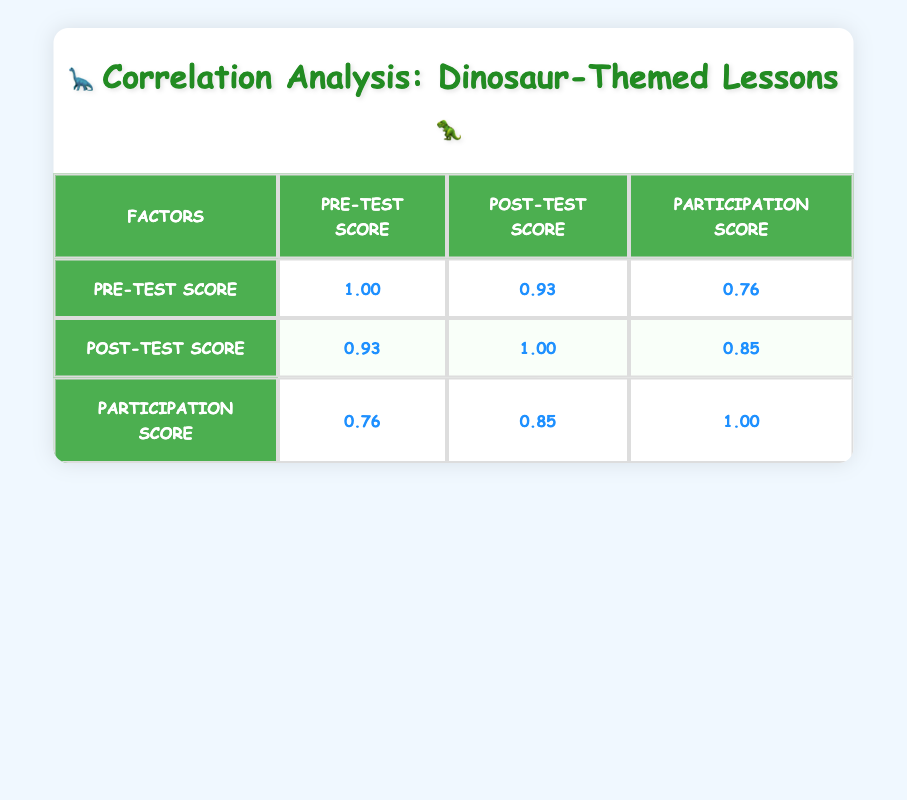What is the correlation coefficient between pre-test scores and post-test scores? The table shows that the correlation coefficient between pre-test scores and post-test scores is 0.95. This value is located in the cell where the "Pre-Test Score" row intersects with the "Post-Test Score" column.
Answer: 0.95 What is the highest correlation score in the table? The highest correlation score in the table is 1.00, which occurs between the pre-test scores and themselves, as well as the post-test scores and themselves. This can be seen in the diagonal cells of the table.
Answer: 1.00 What is the average participation score? To find the average participation score, sum up all the participation scores (9 + 7 + 10 + 6 + 8 + 5 + 8 + 7 + 9 + 6 = 75) and divide by the number of students (10). Thus, the average is 75/10 = 7.5.
Answer: 7.5 Is there a strong correlation between participation scores and post-test scores? The correlation coefficient between participation scores and post-test scores is 0.89, which indicates a strong positive correlation. Since this value is close to 1, it suggests that higher participation scores are associated with higher post-test scores.
Answer: Yes What is the difference in correlation coefficients between participation and pre-test scores versus participation and post-test scores? The correlation coefficient between participation and pre-test scores is 0.82, while the correlation with post-test scores is 0.89. The difference is calculated as 0.89 - 0.82 = 0.07, meaning that participation is slightly more correlated with post-test scores than with pre-test scores.
Answer: 0.07 